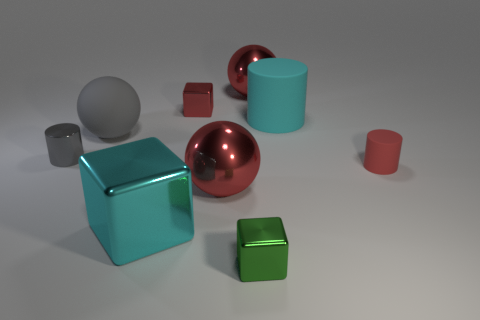What size is the cube that is the same color as the big cylinder?
Offer a terse response. Large. What is the color of the large matte thing that is right of the red metallic thing right of the cube that is in front of the cyan shiny object?
Your answer should be compact. Cyan. Is the shape of the gray object on the left side of the gray sphere the same as  the cyan shiny thing?
Make the answer very short. No. What number of blue shiny things are there?
Your response must be concise. 0. What number of red rubber cylinders are the same size as the gray shiny cylinder?
Your answer should be very brief. 1. What is the tiny green cube made of?
Keep it short and to the point. Metal. There is a big shiny cube; does it have the same color as the large matte thing that is right of the green metal thing?
Provide a succinct answer. Yes. What is the size of the block that is in front of the large cylinder and on the left side of the green block?
Provide a short and direct response. Large. What shape is the small green thing that is made of the same material as the red block?
Offer a very short reply. Cube. Does the small gray thing have the same material as the big red object behind the gray matte sphere?
Give a very brief answer. Yes. 